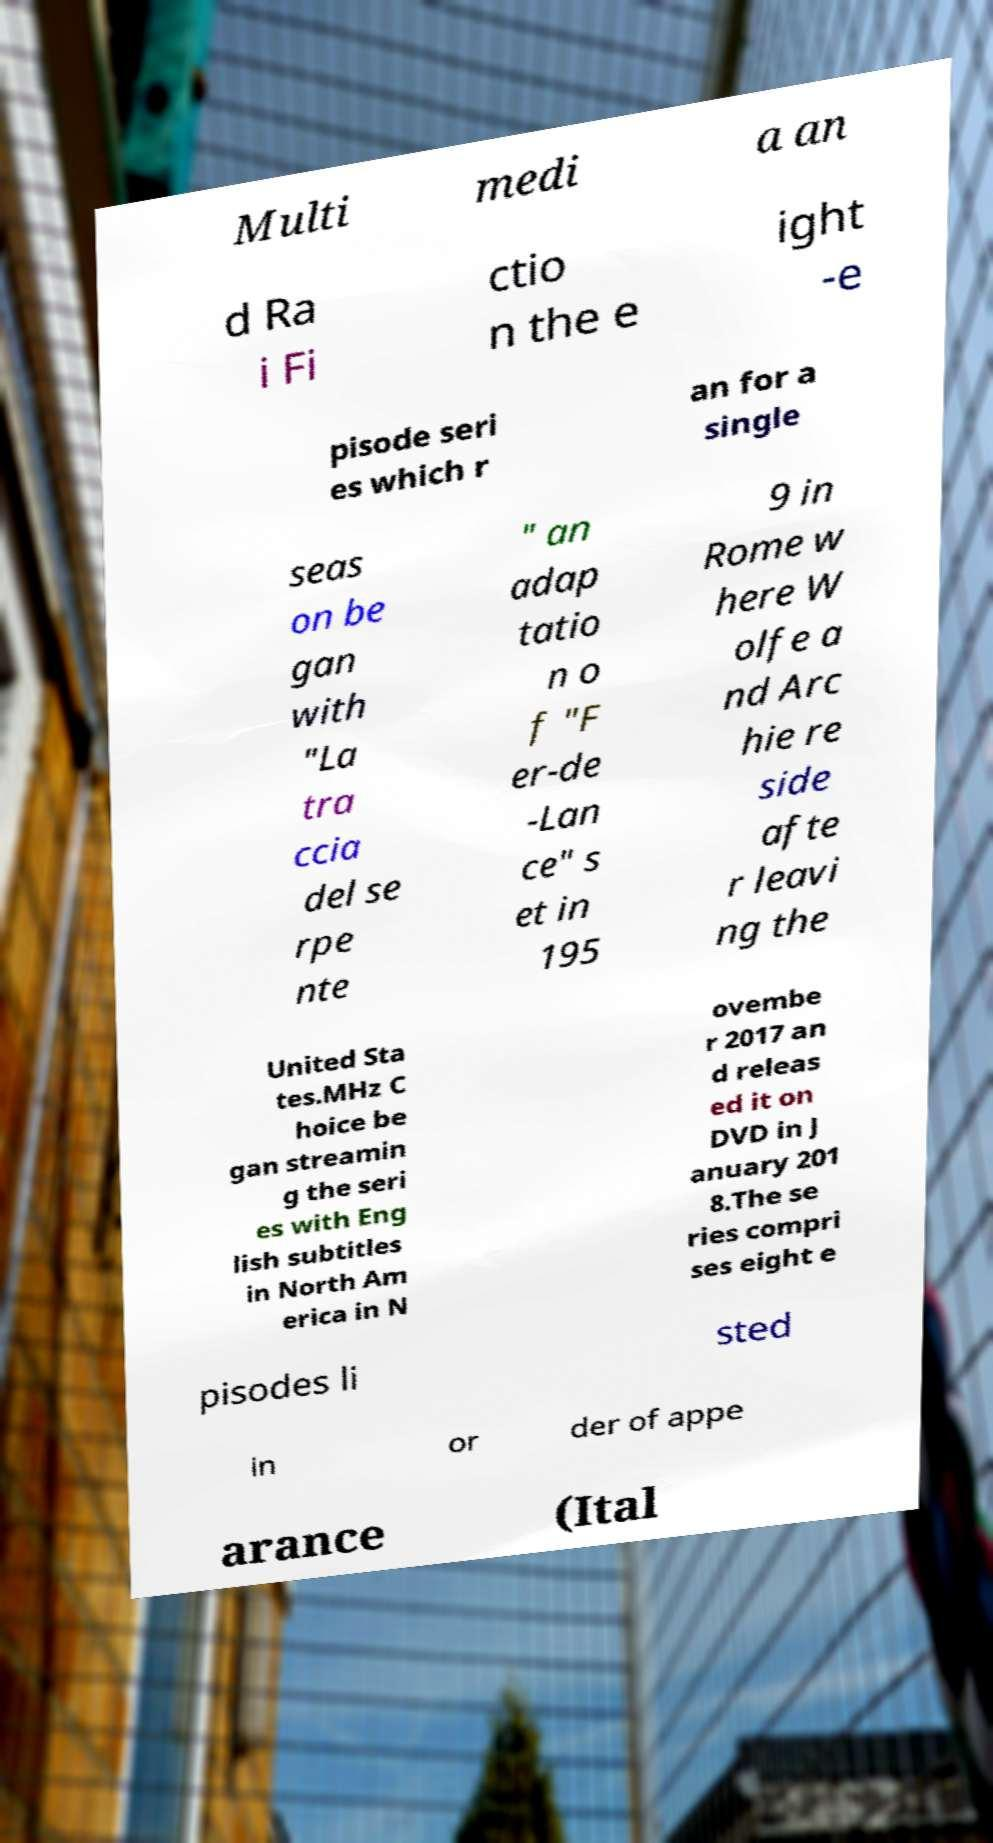Can you accurately transcribe the text from the provided image for me? Multi medi a an d Ra i Fi ctio n the e ight -e pisode seri es which r an for a single seas on be gan with "La tra ccia del se rpe nte " an adap tatio n o f "F er-de -Lan ce" s et in 195 9 in Rome w here W olfe a nd Arc hie re side afte r leavi ng the United Sta tes.MHz C hoice be gan streamin g the seri es with Eng lish subtitles in North Am erica in N ovembe r 2017 an d releas ed it on DVD in J anuary 201 8.The se ries compri ses eight e pisodes li sted in or der of appe arance (Ital 